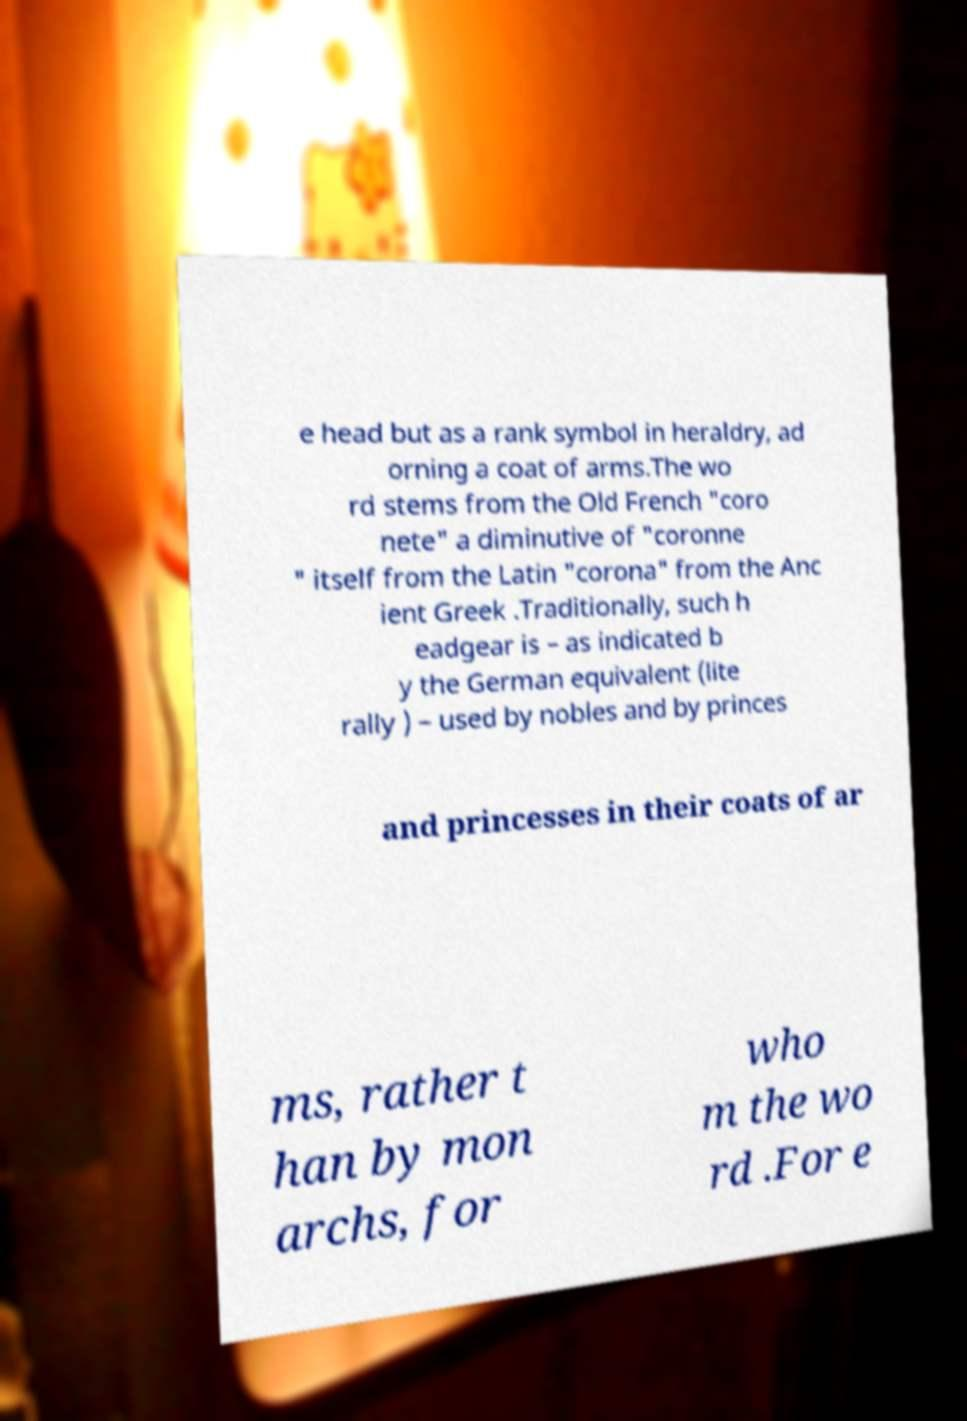For documentation purposes, I need the text within this image transcribed. Could you provide that? e head but as a rank symbol in heraldry, ad orning a coat of arms.The wo rd stems from the Old French "coro nete" a diminutive of "coronne " itself from the Latin "corona" from the Anc ient Greek .Traditionally, such h eadgear is – as indicated b y the German equivalent (lite rally ) – used by nobles and by princes and princesses in their coats of ar ms, rather t han by mon archs, for who m the wo rd .For e 